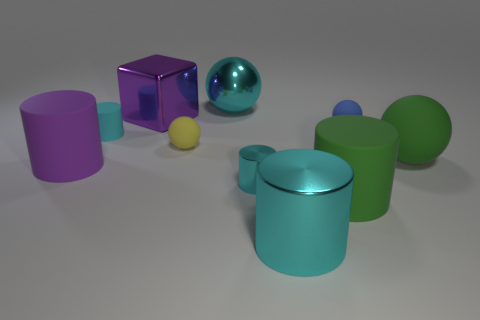Is there anything else that is the same shape as the purple shiny object?
Your response must be concise. No. There is a large rubber object that is the same color as the metal block; what shape is it?
Make the answer very short. Cylinder. Do the rubber cylinder behind the large purple rubber cylinder and the matte cylinder that is to the right of the big cyan metal sphere have the same size?
Your answer should be compact. No. How many balls are either green matte things or big purple metallic objects?
Your response must be concise. 1. Are the green object in front of the purple cylinder and the big cyan cylinder made of the same material?
Give a very brief answer. No. How many other things are the same size as the blue matte object?
Your answer should be very brief. 3. How many large things are either cubes or shiny spheres?
Offer a very short reply. 2. Is the large shiny cylinder the same color as the big metallic ball?
Keep it short and to the point. Yes. Is the number of big metallic spheres that are left of the big cyan sphere greater than the number of large matte spheres that are to the left of the large metal cylinder?
Provide a short and direct response. No. There is a big sphere that is behind the cyan rubber object; does it have the same color as the small metallic thing?
Offer a very short reply. Yes. 